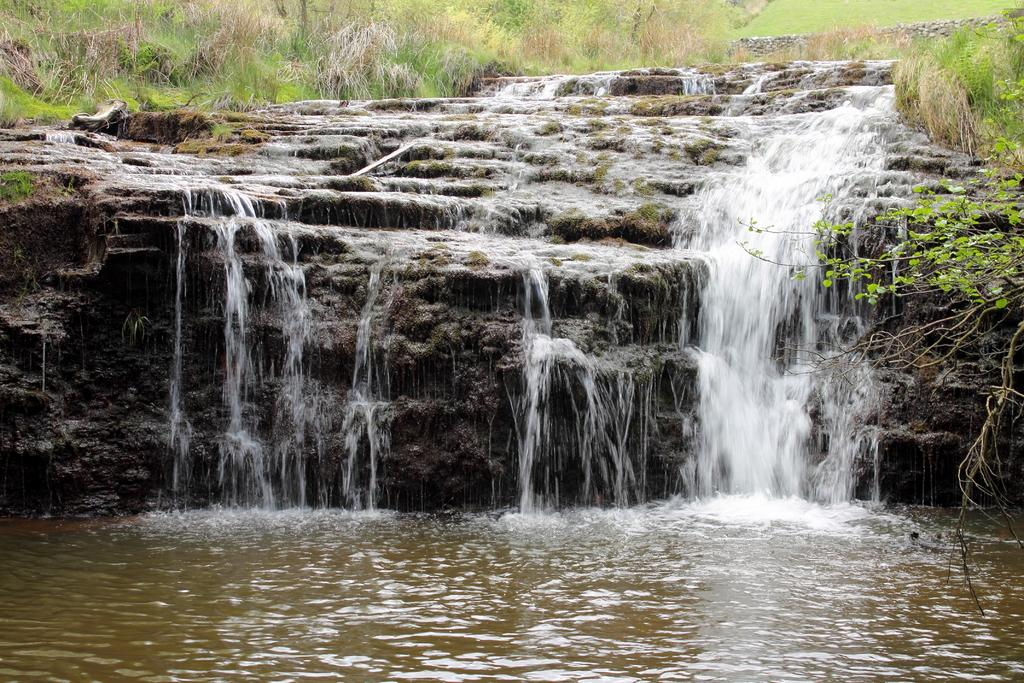What natural feature is the main subject of the image? There is a waterfall in the image. What type of vegetation can be seen behind the waterfall? Grass is visible behind the waterfall. What government policy is being discussed in the image? There is no discussion or reference to any government policy in the image; it features a waterfall and grass. How can one join the waterfall in the image? It is not possible to join the waterfall in the image, as it is a static photograph. 